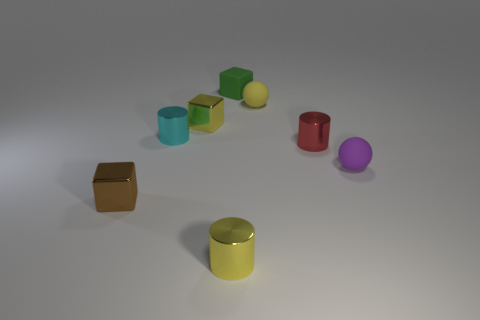Describe the arrangement of the objects. The objects are placed in a diagonal line that extends from the bottom-left to the top-right of the image. Their arrangement seems intentional, as it guides the viewer's eye across the composition, suggesting a sense of movement or progression. 